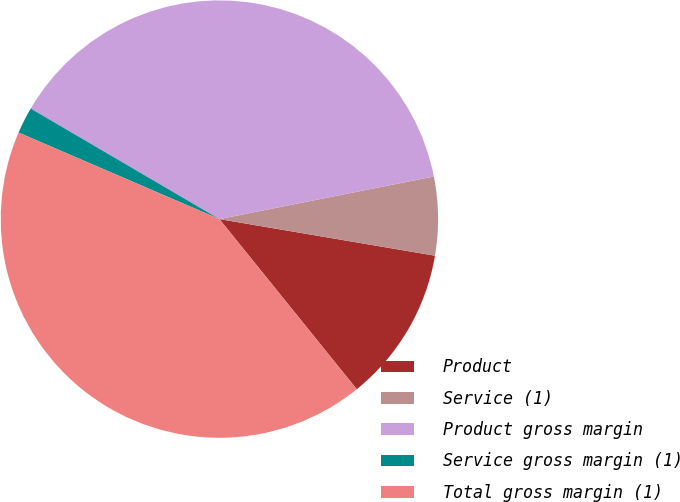<chart> <loc_0><loc_0><loc_500><loc_500><pie_chart><fcel>Product<fcel>Service (1)<fcel>Product gross margin<fcel>Service gross margin (1)<fcel>Total gross margin (1)<nl><fcel>11.51%<fcel>5.8%<fcel>38.44%<fcel>1.96%<fcel>42.28%<nl></chart> 